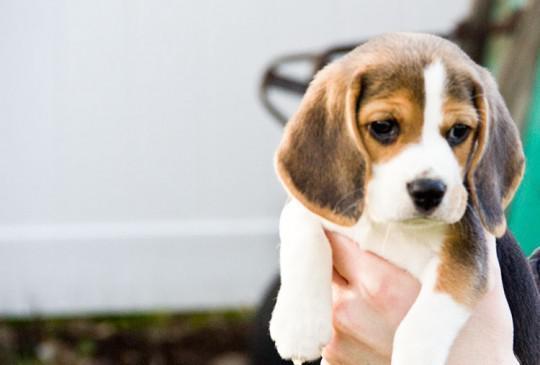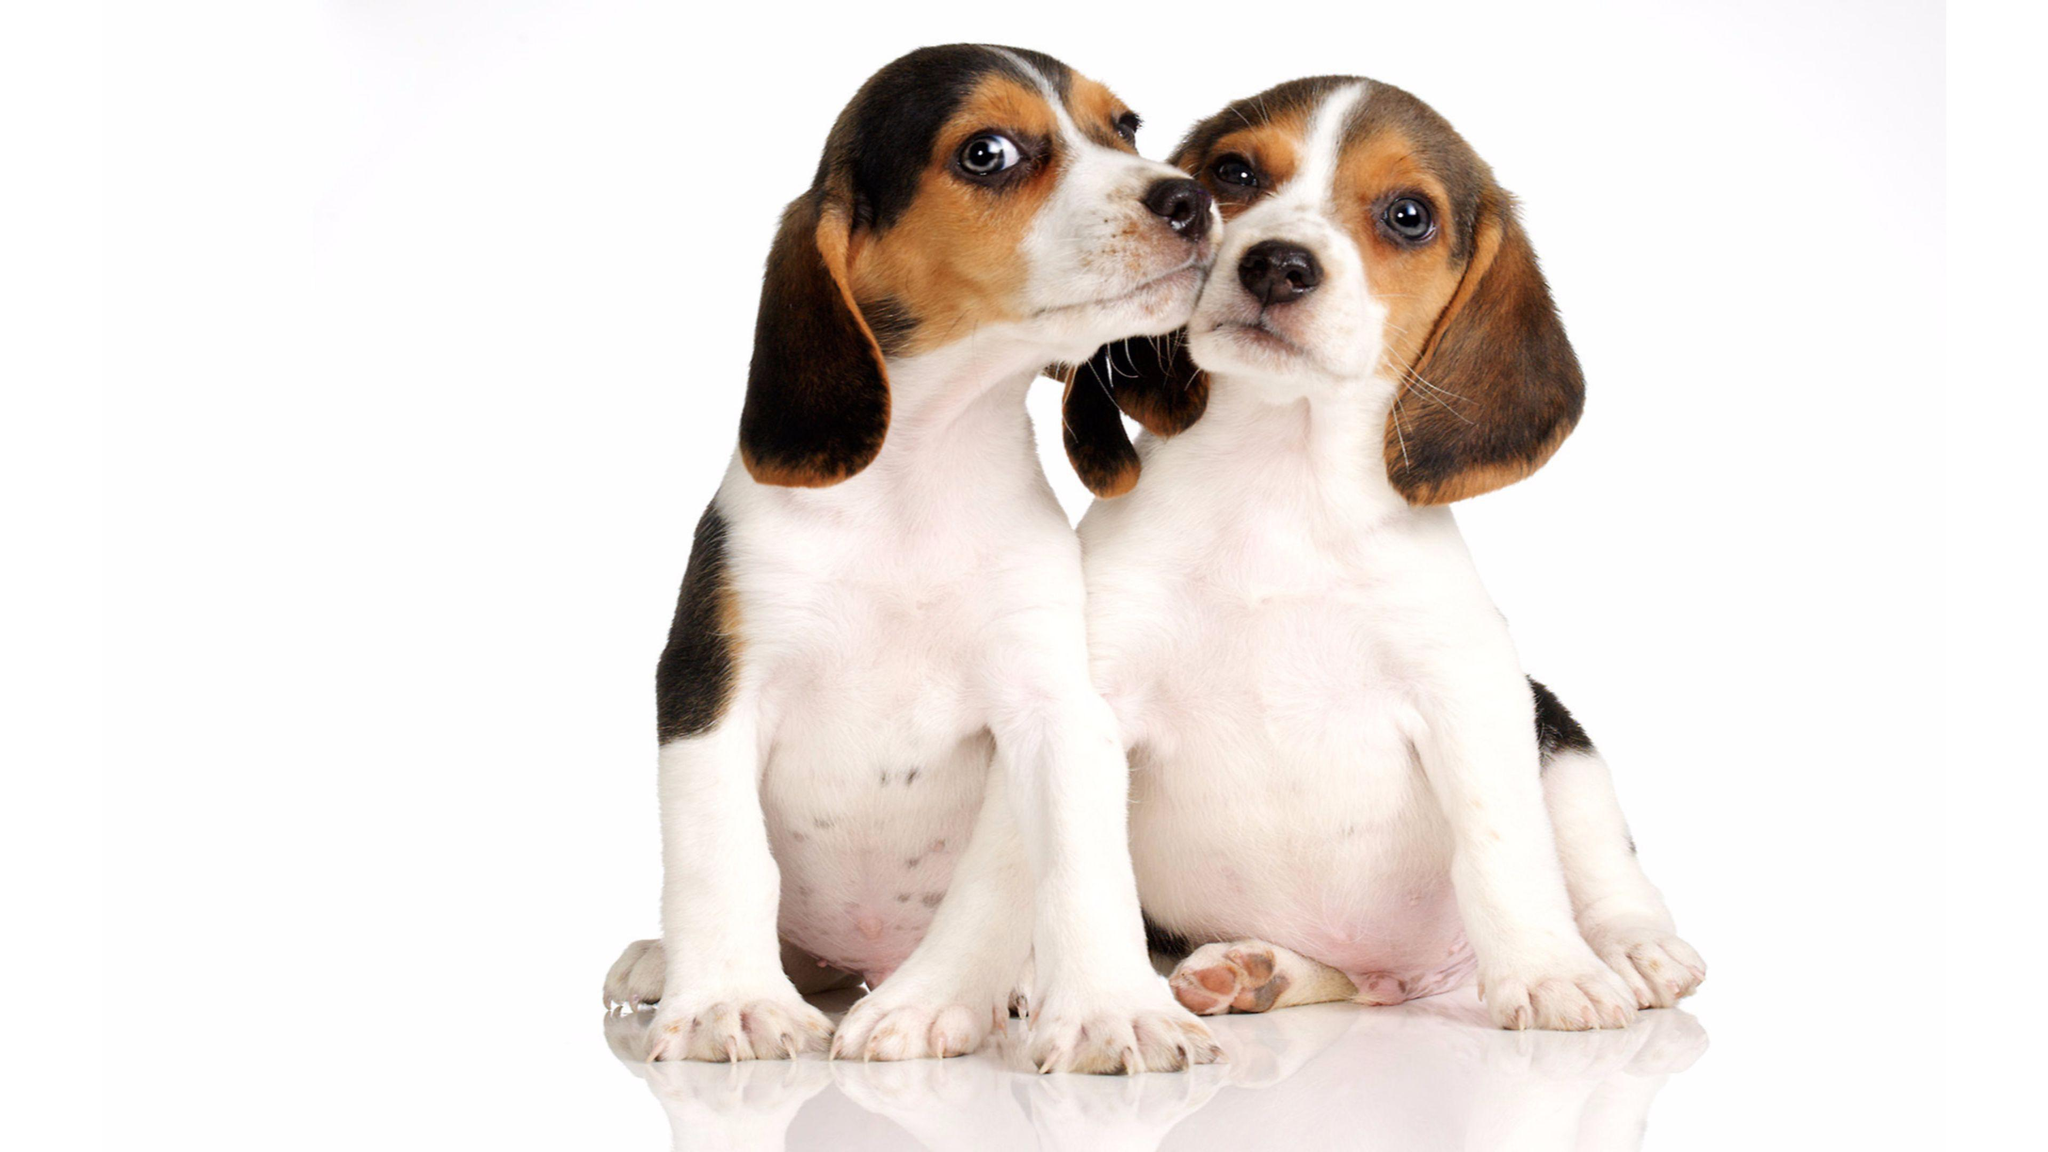The first image is the image on the left, the second image is the image on the right. For the images shown, is this caption "Two dogs are sitting." true? Answer yes or no. Yes. The first image is the image on the left, the second image is the image on the right. For the images shown, is this caption "The dog is looking left, in the image to the left." true? Answer yes or no. No. 